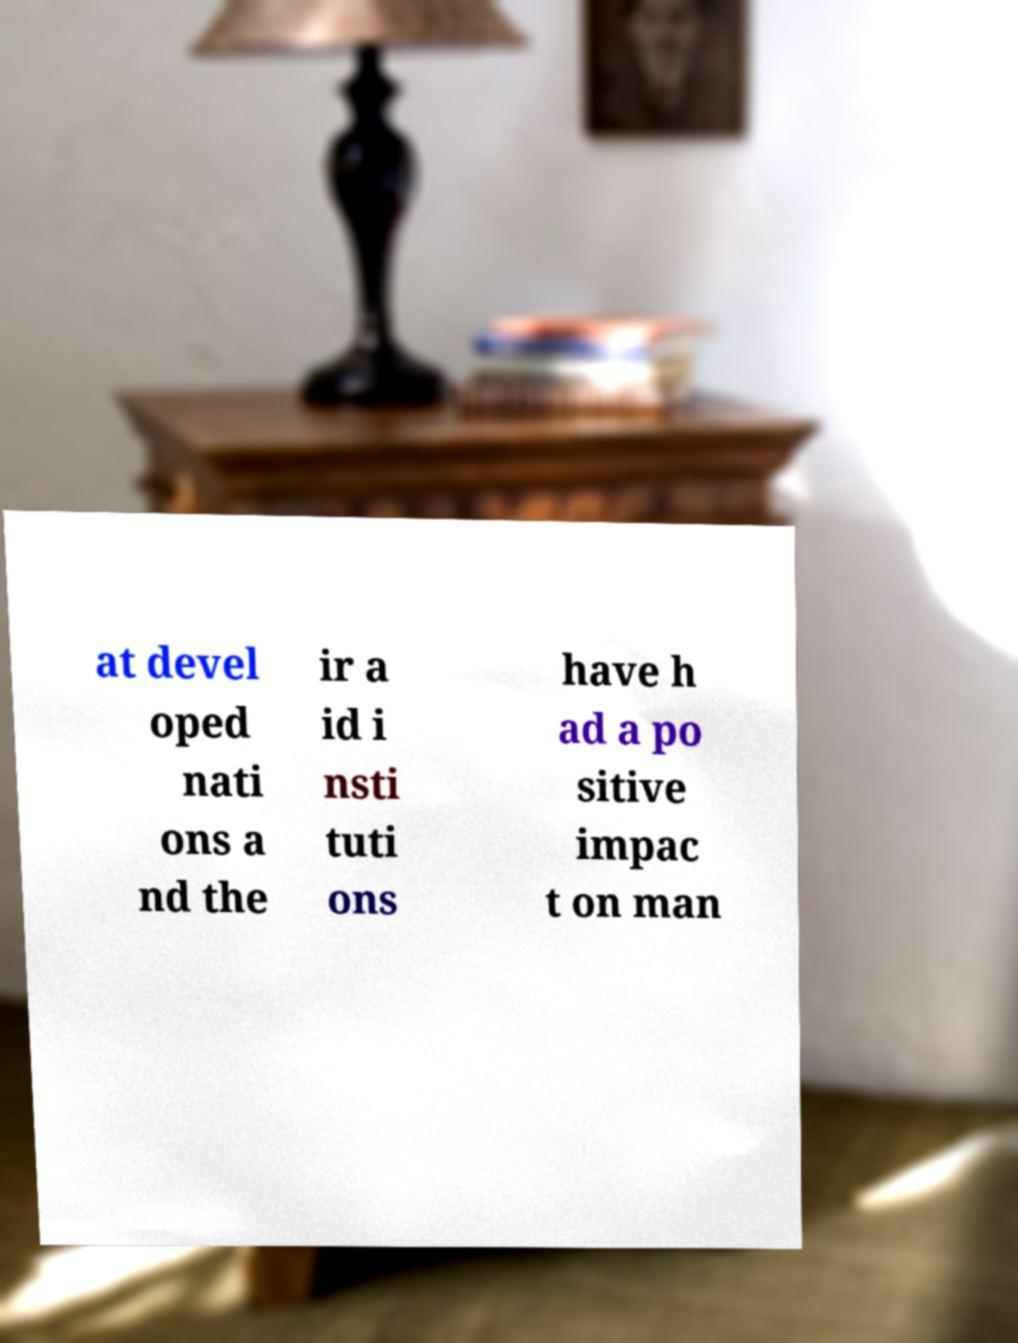Can you accurately transcribe the text from the provided image for me? at devel oped nati ons a nd the ir a id i nsti tuti ons have h ad a po sitive impac t on man 